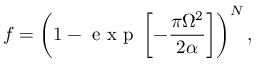Convert formula to latex. <formula><loc_0><loc_0><loc_500><loc_500>f = \left ( 1 - e x p \left [ - \frac { \pi \Omega ^ { 2 } } { 2 \alpha } \right ] \right ) ^ { N } ,</formula> 